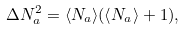Convert formula to latex. <formula><loc_0><loc_0><loc_500><loc_500>\Delta N _ { a } ^ { 2 } = \langle N _ { a } \rangle ( \langle N _ { a } \rangle + 1 ) ,</formula> 